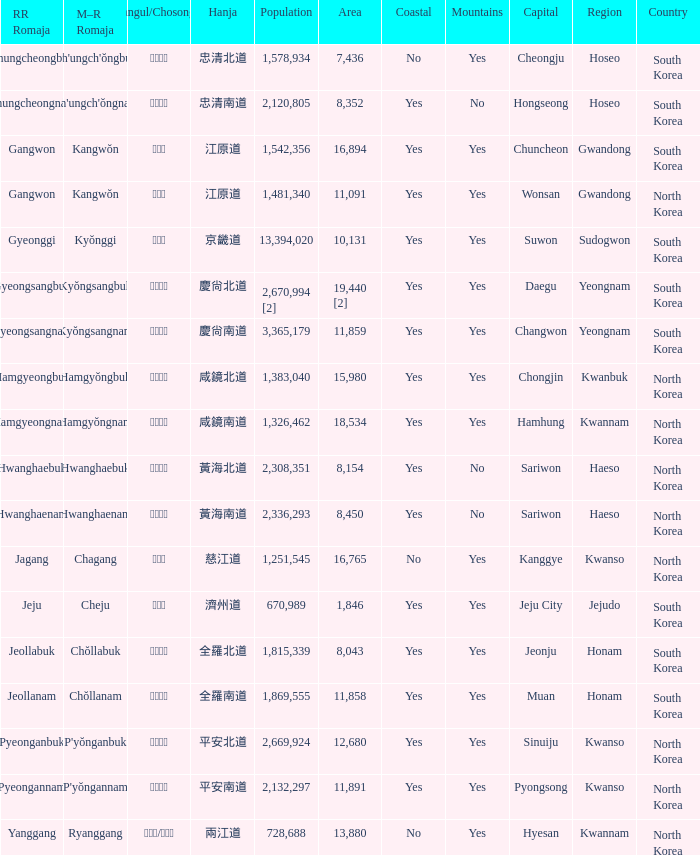Which country has a city with a Hanja of 平安北道? North Korea. 